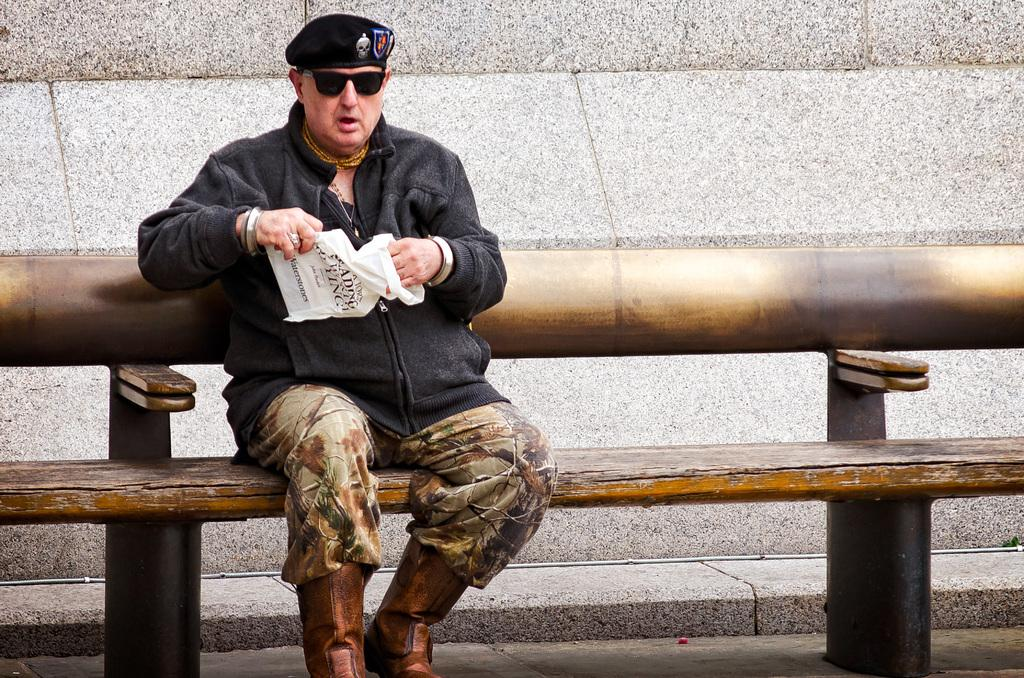What is the person in the image doing? There is a person sitting on a bench in the image. What is the person holding in the image? The person is holding an object. What can be seen in the background of the image? There is a wall visible in the image. What is the name of the science book the person is reading in the image? There is no science book present in the image, nor is the person reading anything. 